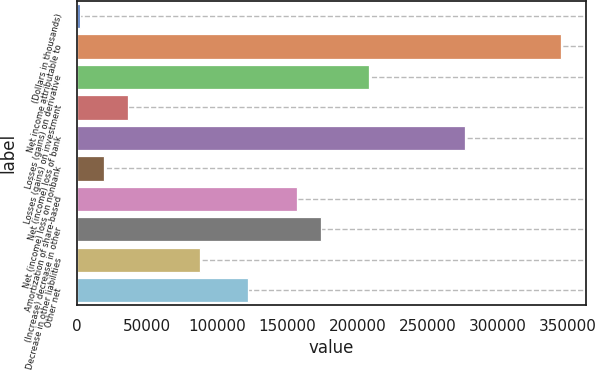Convert chart. <chart><loc_0><loc_0><loc_500><loc_500><bar_chart><fcel>(Dollars in thousands)<fcel>Net income attributable to<fcel>Losses (gains) on derivative<fcel>Losses (gains) on investment<fcel>Net (income) loss of bank<fcel>Net (income) loss on nonbank<fcel>Amortization of share-based<fcel>(Increase) decrease in other<fcel>Decrease in other liabilities<fcel>Other net<nl><fcel>2007<fcel>345563<fcel>208141<fcel>36362.6<fcel>276852<fcel>19184.8<fcel>156607<fcel>173785<fcel>87896<fcel>122252<nl></chart> 